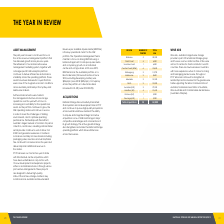According to National Storage Reit's financial document, What was the total NLA in Brisbane? According to the financial document, 25,000. The relevant text states: "Brisbane 5 25,000..." Also, What was the total number of acquisitions in FY19? According to the financial document, 35 acquisitions. The relevant text states: "National Storage has successfully transacted 35 acquisitions and 4 development sites in FY19 and continues to pursue high‑quality acquisitions across Australia..." Also, What are the benefits of active growth strategy? strengthens and scales the National Storage operating platform which drives efficiencies across the business.. The document states: "growth strategy. This active growth strategy also strengthens and scales the National Storage operating platform which drives efficiencies across the ..." Also, can you calculate: What is the sum of centres in Brisbane and Gold Coast? Based on the calculation: 5 + 4, the result is 9. This is based on the information: "Gold Coast 4 6,500 Gold Coast 4 6,500..." The key data points involved are: 4, 5. Also, can you calculate: What is the difference in the NLA between Sunshine Cost and Brisbane? Based on the calculation: 25,000 - 6,500, the result is 18500. This is based on the information: "Gold Coast 4 6,500 Brisbane 5 25,000..." The key data points involved are: 25,000, 6,500. Also, can you calculate: What is the average total NLA of Sunshine Coast and Gold Coast? To answer this question, I need to perform calculations using the financial data. The calculation is: (6,500 + 6,500) / 2, which equals 6500. This is based on the information: "Gold Coast 4 6,500..." 